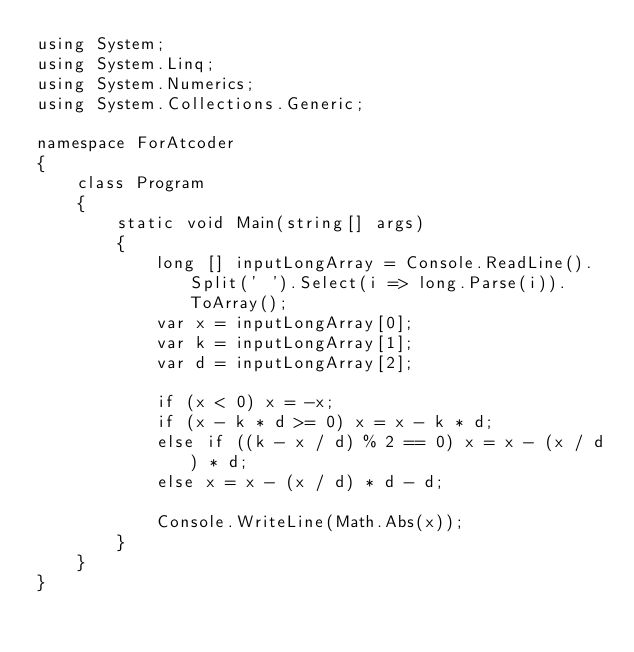<code> <loc_0><loc_0><loc_500><loc_500><_C#_>using System;
using System.Linq;
using System.Numerics;
using System.Collections.Generic;

namespace ForAtcoder
{
    class Program
    {
        static void Main(string[] args)
        {
            long [] inputLongArray = Console.ReadLine().Split(' ').Select(i => long.Parse(i)).ToArray();
            var x = inputLongArray[0];
            var k = inputLongArray[1];
            var d = inputLongArray[2];

            if (x < 0) x = -x;
            if (x - k * d >= 0) x = x - k * d;
            else if ((k - x / d) % 2 == 0) x = x - (x / d) * d;
            else x = x - (x / d) * d - d;

            Console.WriteLine(Math.Abs(x));
        }
    }
}</code> 